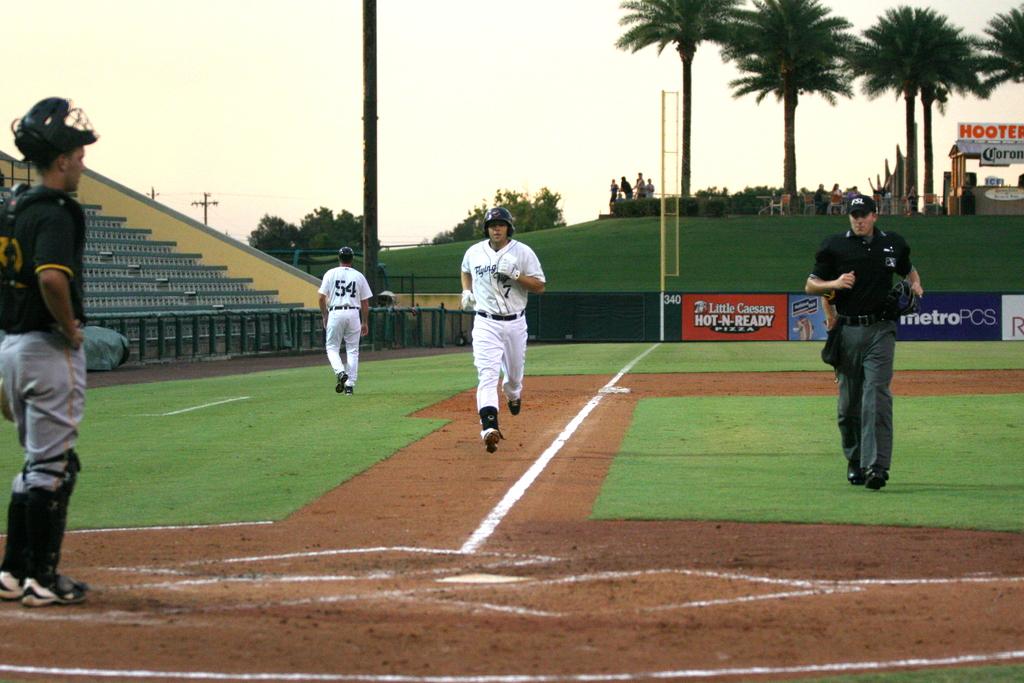What number is the player jogging towards home plate?
Provide a short and direct response. 7. What number is the player walking away?
Your response must be concise. 54. 